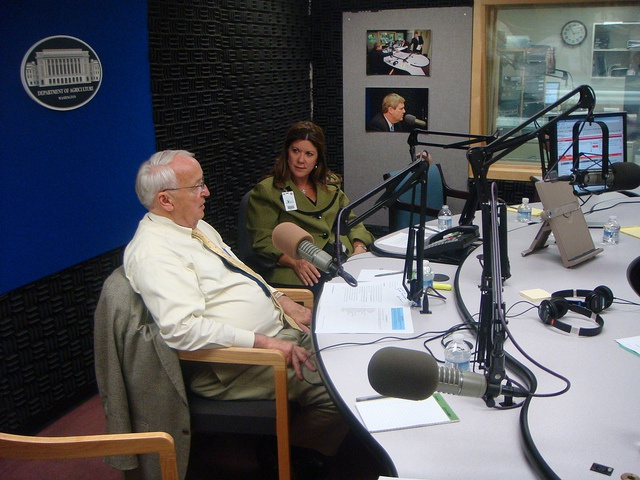Describe the objects in this image and their specific colors. I can see people in black, ivory, gray, and darkgray tones, people in black, darkgreen, maroon, and brown tones, chair in black, maroon, and gray tones, chair in black, maroon, and tan tones, and chair in black, darkblue, blue, and gray tones in this image. 